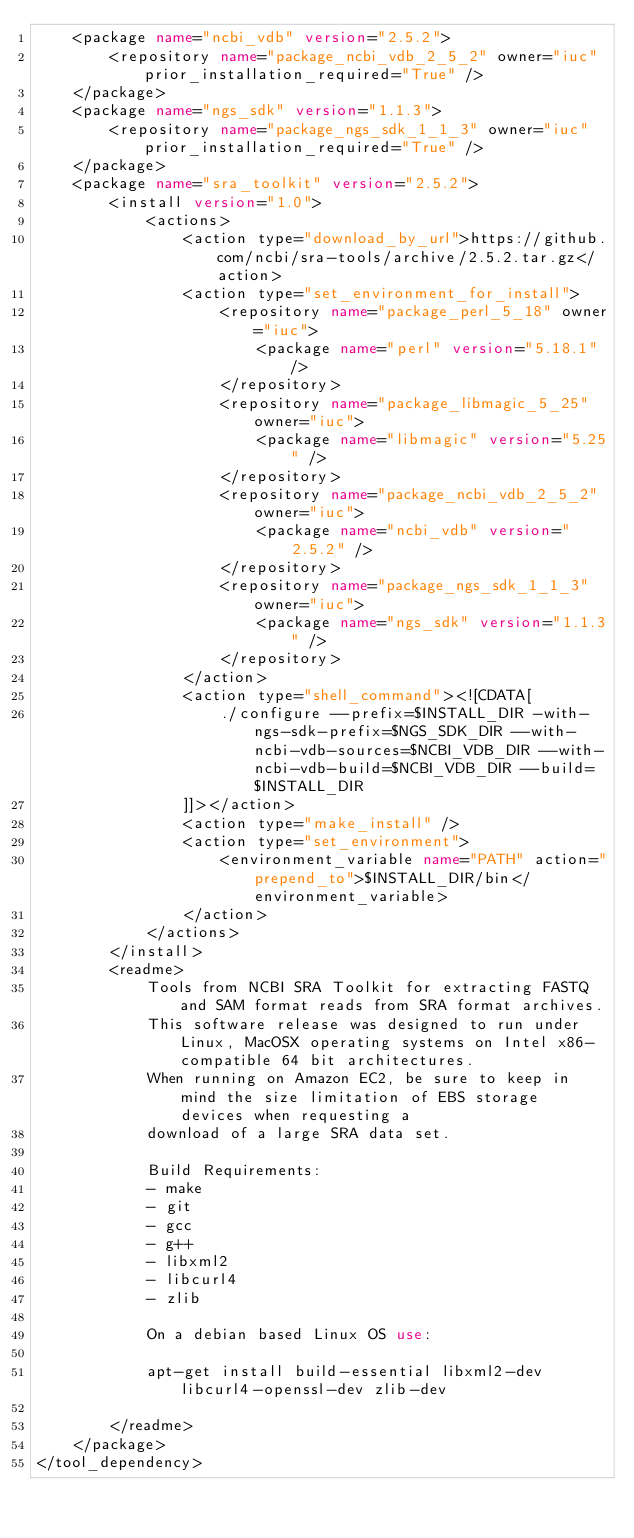<code> <loc_0><loc_0><loc_500><loc_500><_XML_>    <package name="ncbi_vdb" version="2.5.2">
        <repository name="package_ncbi_vdb_2_5_2" owner="iuc" prior_installation_required="True" />
    </package>
    <package name="ngs_sdk" version="1.1.3">
        <repository name="package_ngs_sdk_1_1_3" owner="iuc" prior_installation_required="True" />
    </package>
    <package name="sra_toolkit" version="2.5.2">
        <install version="1.0">
            <actions>
                <action type="download_by_url">https://github.com/ncbi/sra-tools/archive/2.5.2.tar.gz</action>
                <action type="set_environment_for_install">
                    <repository name="package_perl_5_18" owner="iuc">
                        <package name="perl" version="5.18.1" />
                    </repository>
                    <repository name="package_libmagic_5_25" owner="iuc">
                        <package name="libmagic" version="5.25" />
                    </repository>
                    <repository name="package_ncbi_vdb_2_5_2" owner="iuc">
                        <package name="ncbi_vdb" version="2.5.2" />
                    </repository>
                    <repository name="package_ngs_sdk_1_1_3" owner="iuc">
                        <package name="ngs_sdk" version="1.1.3" />
                    </repository>
                </action>
                <action type="shell_command"><![CDATA[
                    ./configure --prefix=$INSTALL_DIR -with-ngs-sdk-prefix=$NGS_SDK_DIR --with-ncbi-vdb-sources=$NCBI_VDB_DIR --with-ncbi-vdb-build=$NCBI_VDB_DIR --build=$INSTALL_DIR
                ]]></action>
                <action type="make_install" />
                <action type="set_environment">
                    <environment_variable name="PATH" action="prepend_to">$INSTALL_DIR/bin</environment_variable>
                </action>
            </actions>
        </install>
        <readme>
            Tools from NCBI SRA Toolkit for extracting FASTQ and SAM format reads from SRA format archives.
            This software release was designed to run under Linux, MacOSX operating systems on Intel x86-compatible 64 bit architectures.
            When running on Amazon EC2, be sure to keep in mind the size limitation of EBS storage devices when requesting a
            download of a large SRA data set.

            Build Requirements:
            - make
            - git
            - gcc
            - g++
            - libxml2
            - libcurl4
            - zlib

            On a debian based Linux OS use:

            apt-get install build-essential libxml2-dev libcurl4-openssl-dev zlib-dev

        </readme>
    </package>
</tool_dependency>
</code> 